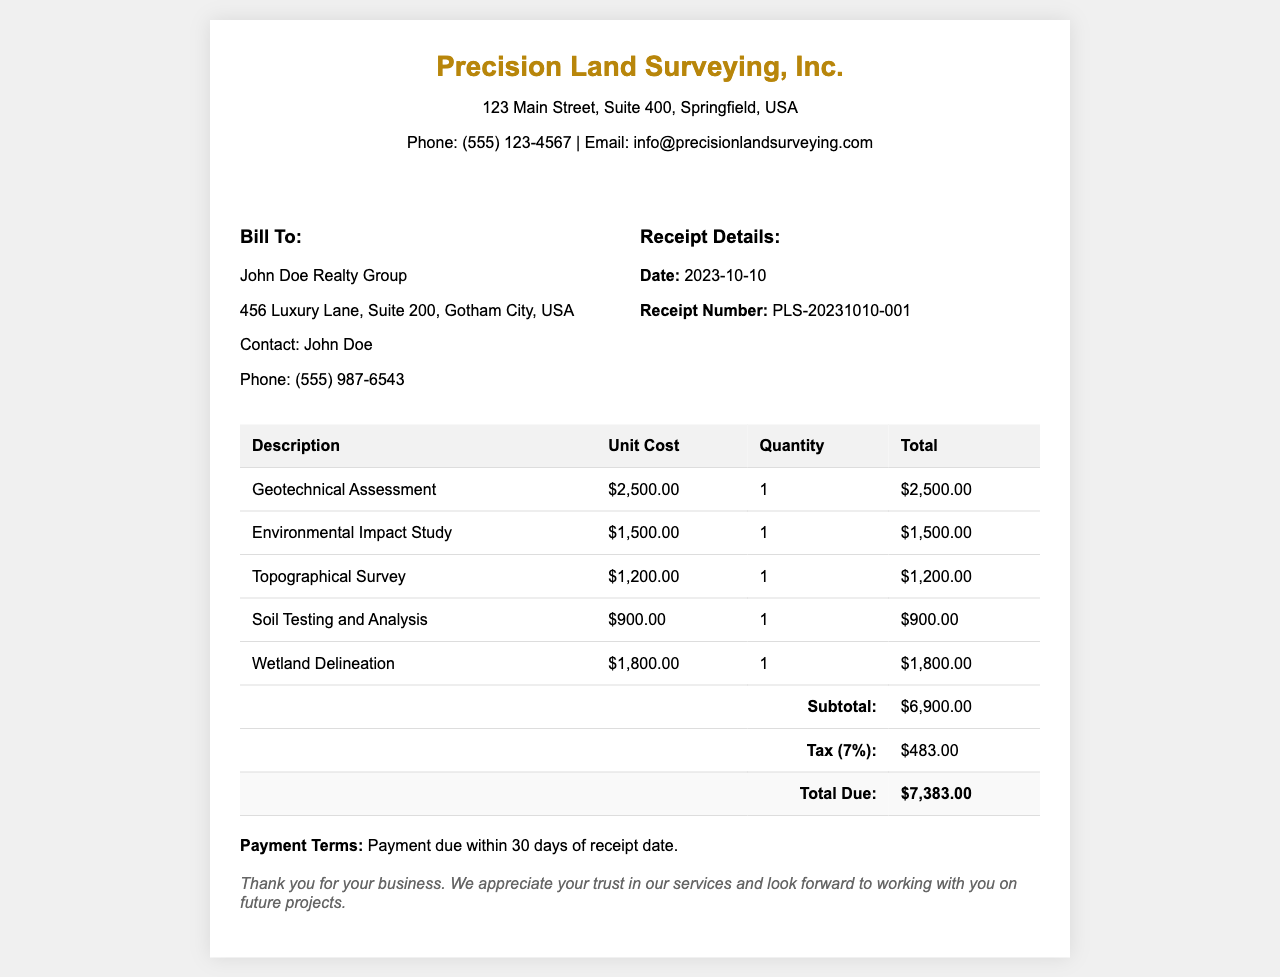What is the company name? The company name is listed at the top of the receipt as Precision Land Surveying, Inc.
Answer: Precision Land Surveying, Inc What is the total due amount? The total due is found at the bottom of the table, summing the subtotal and tax.
Answer: $7,383.00 When was the receipt issued? The receipt date is mentioned in the receipt details section.
Answer: 2023-10-10 Who is the contact for the billing client? The contact is stated in the client information section as John Doe.
Answer: John Doe What type of assessment is the most expensive? The most expensive assessment is identified by comparing the unit costs in the table.
Answer: Geotechnical Assessment What is the tax percentage applied? The tax percentage is indicated in the tax row of the document.
Answer: 7% How many services are itemized in the document? The number of listed services is derived from counting the rows in the table.
Answer: 5 What is the address of the company? The company's address is provided under the company name in the header section.
Answer: 123 Main Street, Suite 400, Springfield, USA What is the payment term specified? The payment term is mentioned in a separate statement at the bottom of the receipt.
Answer: Payment due within 30 days of receipt date 